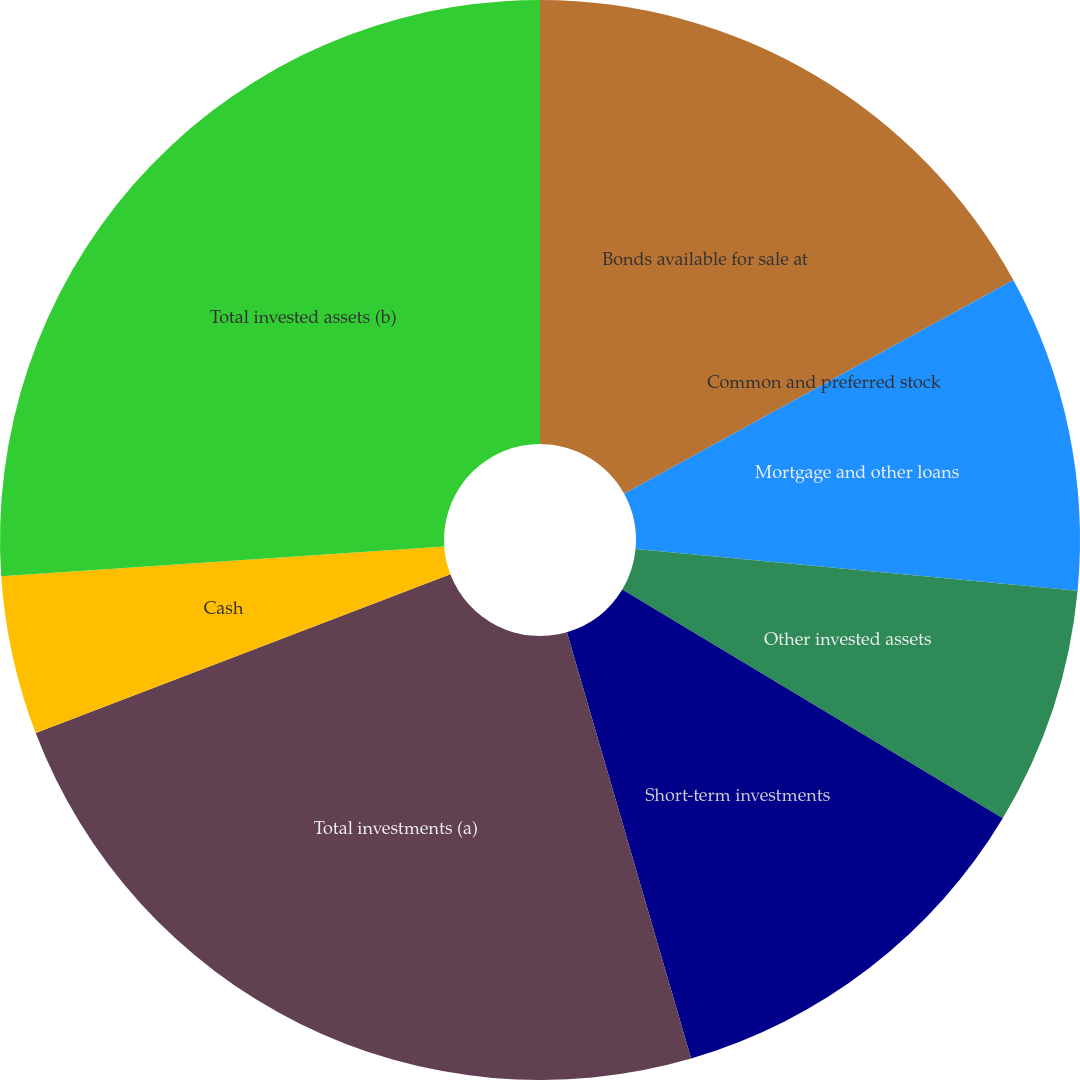Convert chart to OTSL. <chart><loc_0><loc_0><loc_500><loc_500><pie_chart><fcel>Bonds available for sale at<fcel>Common and preferred stock<fcel>Mortgage and other loans<fcel>Other invested assets<fcel>Short-term investments<fcel>Total investments (a)<fcel>Cash<fcel>Total invested assets (b)<nl><fcel>17.01%<fcel>0.0%<fcel>9.49%<fcel>7.12%<fcel>11.87%<fcel>23.7%<fcel>4.75%<fcel>26.07%<nl></chart> 